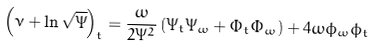<formula> <loc_0><loc_0><loc_500><loc_500>\left ( \nu + \ln \sqrt { \Psi } \right ) _ { t } = \frac { \omega } { 2 \Psi ^ { 2 } } \left ( \Psi _ { t } \Psi _ { \omega } + \Phi _ { t } \Phi _ { \omega } \right ) + 4 \omega \phi _ { \omega } \phi _ { t }</formula> 